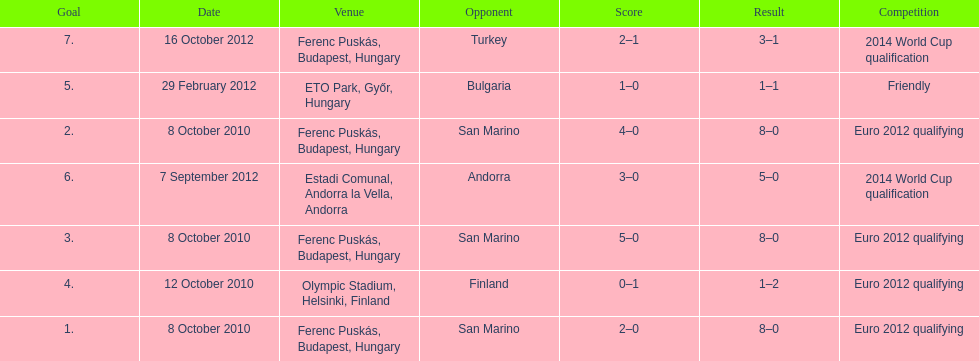What is the total number of international goals ádám szalai has made? 7. 